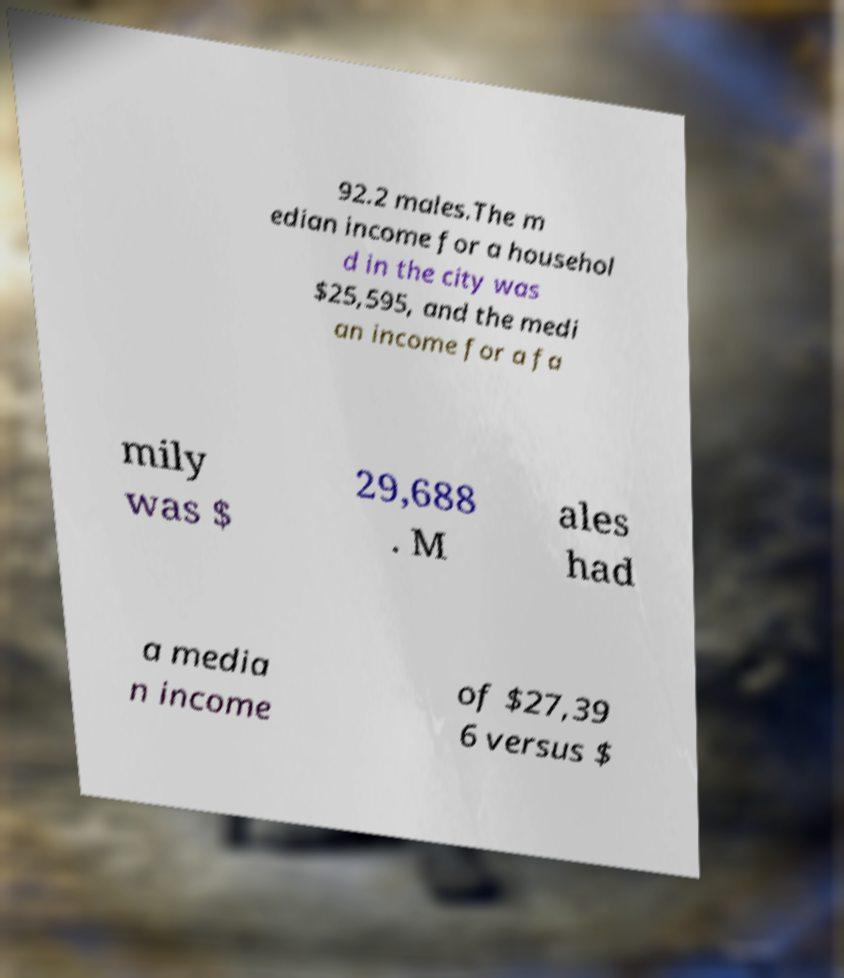What messages or text are displayed in this image? I need them in a readable, typed format. 92.2 males.The m edian income for a househol d in the city was $25,595, and the medi an income for a fa mily was $ 29,688 . M ales had a media n income of $27,39 6 versus $ 